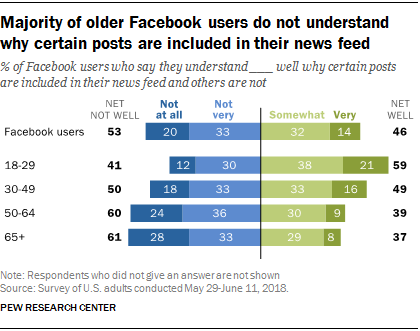Identify some key points in this picture. The percentage of people choosing very well is 68%. The age range of 18-29 is more likely to choose very well. 